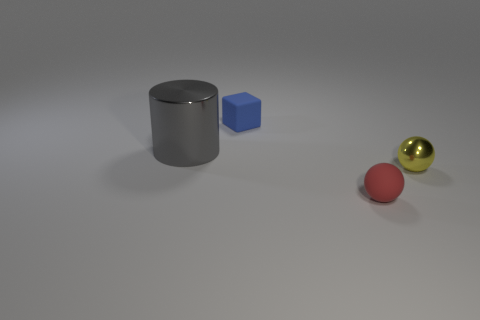Is there any other thing that is the same size as the gray metal thing?
Ensure brevity in your answer.  No. There is a small shiny thing; how many balls are to the left of it?
Your answer should be compact. 1. What is the shape of the tiny rubber thing that is behind the metallic thing that is on the left side of the small yellow thing?
Your answer should be compact. Cube. Is there anything else that has the same shape as the blue object?
Your response must be concise. No. Is the number of small things behind the gray object greater than the number of large blue cylinders?
Your answer should be very brief. Yes. What number of metal things are to the right of the thing that is in front of the yellow object?
Provide a succinct answer. 1. There is a tiny object on the left side of the tiny rubber object in front of the metal thing to the right of the small cube; what is its shape?
Your response must be concise. Cube. What is the size of the gray metallic cylinder?
Provide a short and direct response. Large. Are there any red balls that have the same material as the tiny blue cube?
Ensure brevity in your answer.  Yes. Is the number of large things that are on the left side of the yellow object the same as the number of large yellow blocks?
Provide a succinct answer. No. 